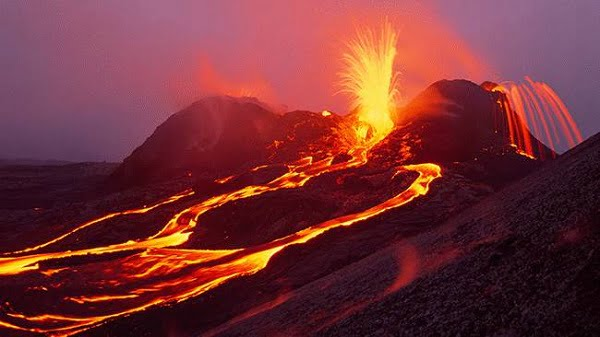How do scientists monitor and predict volcanic eruptions like the one shown? Scientists employ a variety of monitoring techniques to predict volcanic eruptions. They use seismographs to detect earthquakes that often precede eruptions. Satellite and aerial imagery provide visuals of the volcano's surface changes, while gas emissions are analyzed for changes in composition. Ground deformation is measured with GPS to detect swelling of the volcano, which can signal magma movement. All these data are combined to forecast potential eruptions and issue warnings to minimize the risk to populations nearby. What safeguards do communities have in place for such events? Communities near active volcanoes typically have detailed evacuation plans and early warning systems to alert residents of imminent eruptions. Buildings and infrastructure are often designed to be more resistant to ash fall and lava flows. Emergency response teams are trained to deal with volcanic crises, and public education campaigns inform residents about how to prepare for and respond to volcanic activity. 